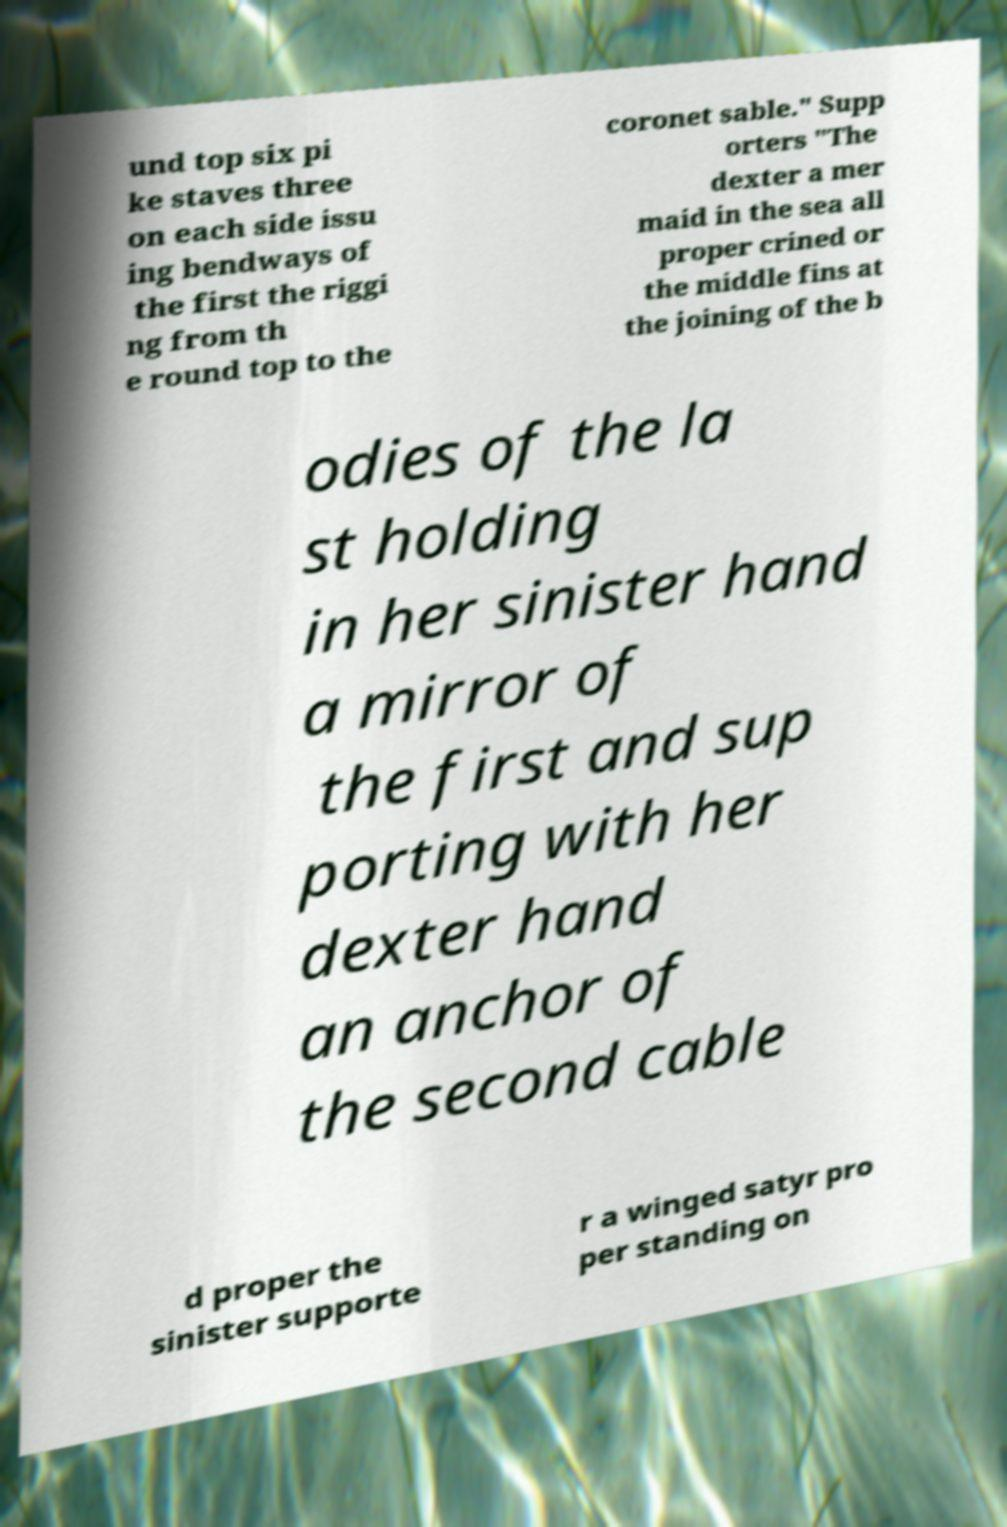What messages or text are displayed in this image? I need them in a readable, typed format. und top six pi ke staves three on each side issu ing bendways of the first the riggi ng from th e round top to the coronet sable." Supp orters "The dexter a mer maid in the sea all proper crined or the middle fins at the joining of the b odies of the la st holding in her sinister hand a mirror of the first and sup porting with her dexter hand an anchor of the second cable d proper the sinister supporte r a winged satyr pro per standing on 